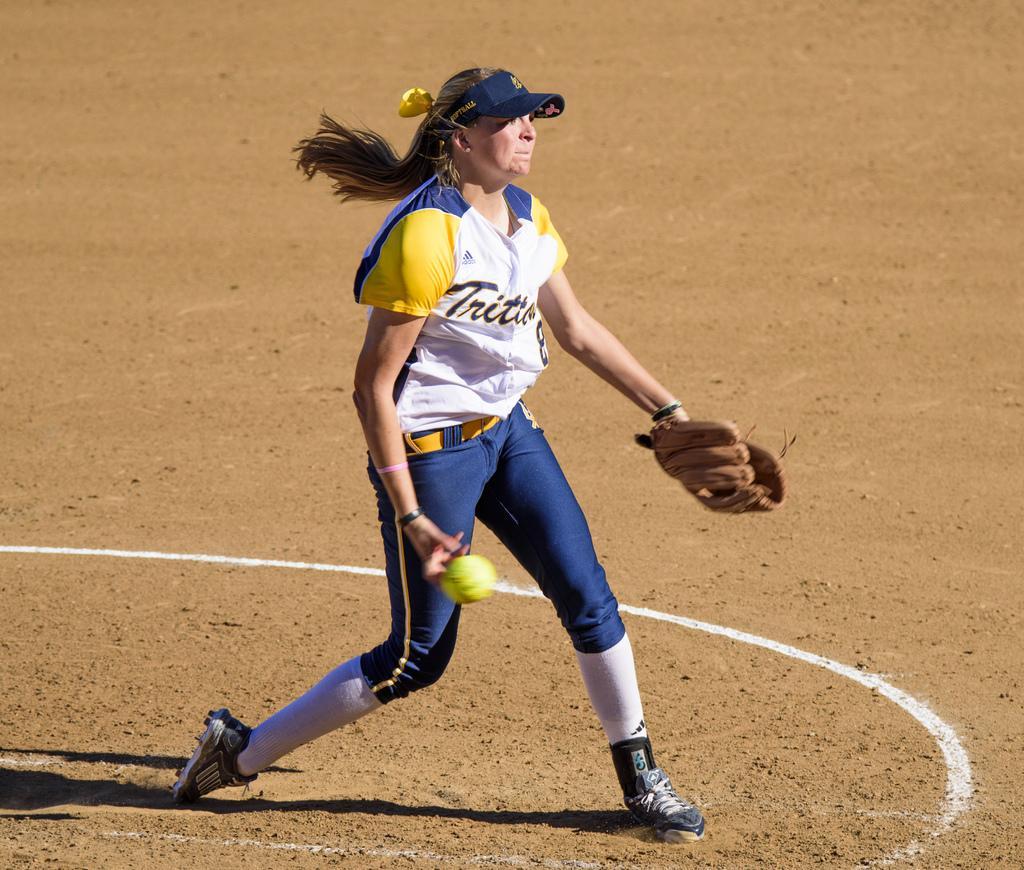Please provide a concise description of this image. In this picture there is a woman standing on the sand and holding a glove in one of her hand and a ball in her another hand. 